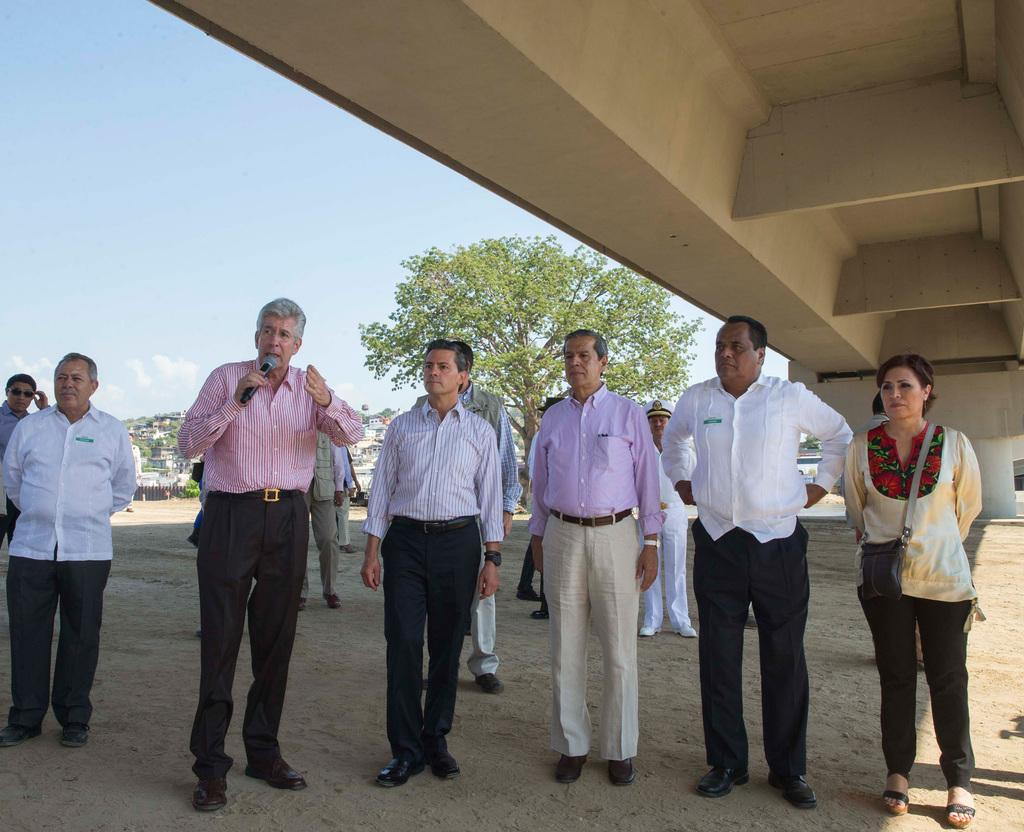Where are the people located in the image? The people are standing under a bridge in the image. What is the man holding in the image? The man is holding a microphone in the image. What can be seen in the background of the image? There are buildings and a tree in the background of the image. What type of plastic toy is the beginner using in the image? There is no plastic toy or beginner present in the image. How many times does the man laugh while holding the microphone in the image? The image does not show the man laughing, nor does it indicate how many times he might laugh. 